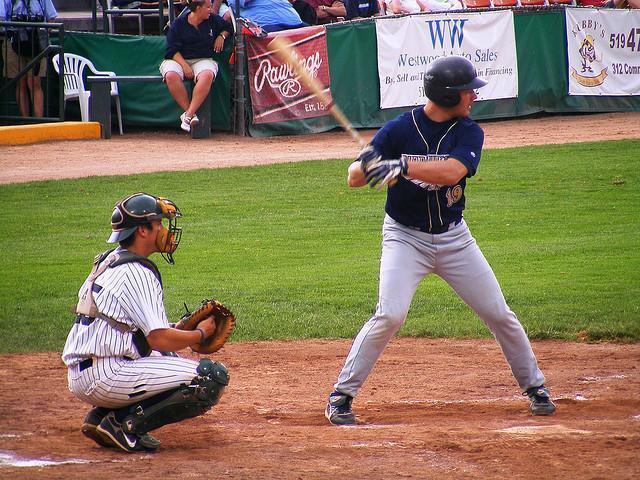How many people are there?
Give a very brief answer. 5. 